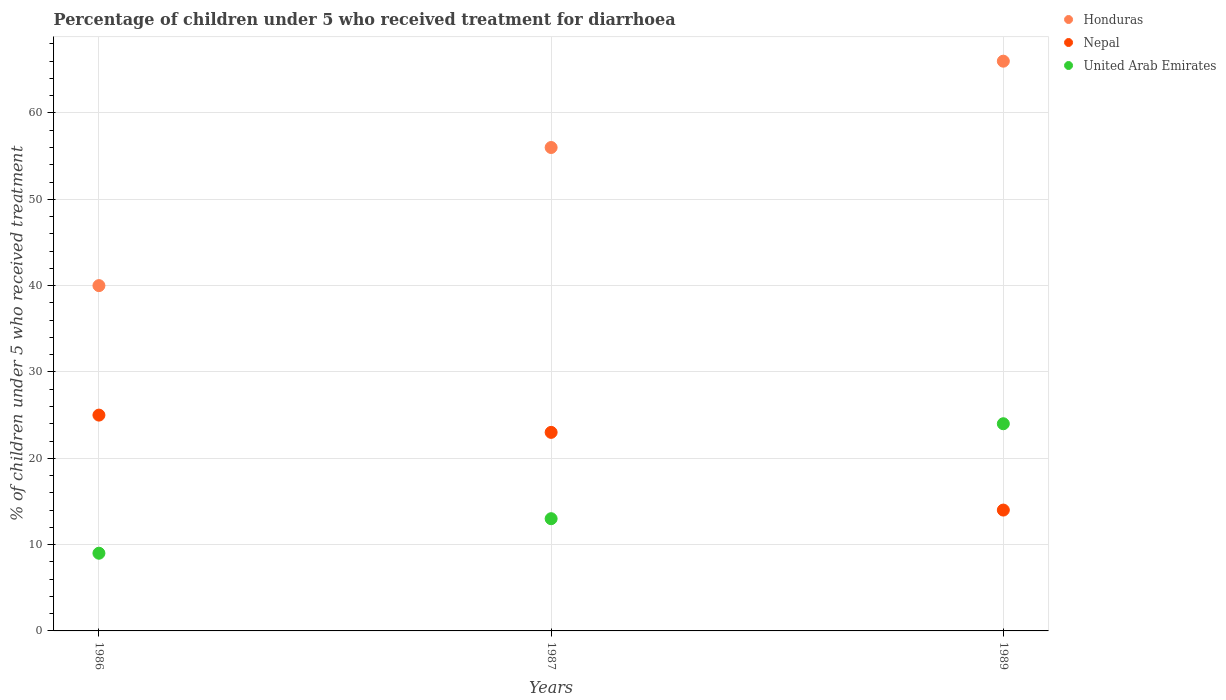How many different coloured dotlines are there?
Your answer should be compact. 3. Is the number of dotlines equal to the number of legend labels?
Make the answer very short. Yes. Across all years, what is the maximum percentage of children who received treatment for diarrhoea  in Nepal?
Keep it short and to the point. 25. In which year was the percentage of children who received treatment for diarrhoea  in Honduras maximum?
Provide a short and direct response. 1989. What is the total percentage of children who received treatment for diarrhoea  in United Arab Emirates in the graph?
Make the answer very short. 46. What is the difference between the percentage of children who received treatment for diarrhoea  in United Arab Emirates in 1987 and that in 1989?
Provide a short and direct response. -11. What is the average percentage of children who received treatment for diarrhoea  in United Arab Emirates per year?
Keep it short and to the point. 15.33. In how many years, is the percentage of children who received treatment for diarrhoea  in United Arab Emirates greater than 20 %?
Offer a very short reply. 1. What is the ratio of the percentage of children who received treatment for diarrhoea  in Nepal in 1986 to that in 1989?
Keep it short and to the point. 1.79. Is the sum of the percentage of children who received treatment for diarrhoea  in United Arab Emirates in 1987 and 1989 greater than the maximum percentage of children who received treatment for diarrhoea  in Nepal across all years?
Offer a terse response. Yes. Does the percentage of children who received treatment for diarrhoea  in United Arab Emirates monotonically increase over the years?
Make the answer very short. Yes. Is the percentage of children who received treatment for diarrhoea  in Nepal strictly greater than the percentage of children who received treatment for diarrhoea  in Honduras over the years?
Offer a very short reply. No. Is the percentage of children who received treatment for diarrhoea  in Nepal strictly less than the percentage of children who received treatment for diarrhoea  in Honduras over the years?
Ensure brevity in your answer.  Yes. How many years are there in the graph?
Provide a succinct answer. 3. Where does the legend appear in the graph?
Offer a terse response. Top right. What is the title of the graph?
Provide a short and direct response. Percentage of children under 5 who received treatment for diarrhoea. What is the label or title of the Y-axis?
Give a very brief answer. % of children under 5 who received treatment. What is the % of children under 5 who received treatment of Honduras in 1986?
Your answer should be very brief. 40. What is the % of children under 5 who received treatment in United Arab Emirates in 1986?
Give a very brief answer. 9. What is the % of children under 5 who received treatment in Nepal in 1989?
Give a very brief answer. 14. What is the % of children under 5 who received treatment of United Arab Emirates in 1989?
Keep it short and to the point. 24. Across all years, what is the maximum % of children under 5 who received treatment of Honduras?
Your answer should be very brief. 66. Across all years, what is the maximum % of children under 5 who received treatment of Nepal?
Your response must be concise. 25. Across all years, what is the minimum % of children under 5 who received treatment in Nepal?
Provide a short and direct response. 14. What is the total % of children under 5 who received treatment in Honduras in the graph?
Your answer should be very brief. 162. What is the total % of children under 5 who received treatment of Nepal in the graph?
Keep it short and to the point. 62. What is the difference between the % of children under 5 who received treatment in Honduras in 1986 and that in 1987?
Ensure brevity in your answer.  -16. What is the difference between the % of children under 5 who received treatment in Nepal in 1986 and that in 1987?
Keep it short and to the point. 2. What is the difference between the % of children under 5 who received treatment of United Arab Emirates in 1987 and that in 1989?
Provide a succinct answer. -11. What is the difference between the % of children under 5 who received treatment of Honduras in 1986 and the % of children under 5 who received treatment of Nepal in 1987?
Give a very brief answer. 17. What is the difference between the % of children under 5 who received treatment in Honduras in 1986 and the % of children under 5 who received treatment in United Arab Emirates in 1987?
Give a very brief answer. 27. What is the difference between the % of children under 5 who received treatment of Nepal in 1986 and the % of children under 5 who received treatment of United Arab Emirates in 1987?
Give a very brief answer. 12. What is the difference between the % of children under 5 who received treatment in Honduras in 1986 and the % of children under 5 who received treatment in Nepal in 1989?
Offer a terse response. 26. What is the difference between the % of children under 5 who received treatment of Nepal in 1986 and the % of children under 5 who received treatment of United Arab Emirates in 1989?
Make the answer very short. 1. What is the difference between the % of children under 5 who received treatment of Honduras in 1987 and the % of children under 5 who received treatment of United Arab Emirates in 1989?
Provide a succinct answer. 32. What is the average % of children under 5 who received treatment in Honduras per year?
Your answer should be very brief. 54. What is the average % of children under 5 who received treatment in Nepal per year?
Keep it short and to the point. 20.67. What is the average % of children under 5 who received treatment of United Arab Emirates per year?
Ensure brevity in your answer.  15.33. In the year 1986, what is the difference between the % of children under 5 who received treatment in Honduras and % of children under 5 who received treatment in Nepal?
Your response must be concise. 15. In the year 1987, what is the difference between the % of children under 5 who received treatment in Honduras and % of children under 5 who received treatment in Nepal?
Your response must be concise. 33. In the year 1987, what is the difference between the % of children under 5 who received treatment in Honduras and % of children under 5 who received treatment in United Arab Emirates?
Provide a short and direct response. 43. What is the ratio of the % of children under 5 who received treatment of Nepal in 1986 to that in 1987?
Your answer should be compact. 1.09. What is the ratio of the % of children under 5 who received treatment of United Arab Emirates in 1986 to that in 1987?
Offer a very short reply. 0.69. What is the ratio of the % of children under 5 who received treatment in Honduras in 1986 to that in 1989?
Give a very brief answer. 0.61. What is the ratio of the % of children under 5 who received treatment of Nepal in 1986 to that in 1989?
Your answer should be very brief. 1.79. What is the ratio of the % of children under 5 who received treatment of Honduras in 1987 to that in 1989?
Ensure brevity in your answer.  0.85. What is the ratio of the % of children under 5 who received treatment in Nepal in 1987 to that in 1989?
Provide a succinct answer. 1.64. What is the ratio of the % of children under 5 who received treatment of United Arab Emirates in 1987 to that in 1989?
Offer a terse response. 0.54. What is the difference between the highest and the second highest % of children under 5 who received treatment of Honduras?
Your answer should be compact. 10. What is the difference between the highest and the second highest % of children under 5 who received treatment of Nepal?
Provide a succinct answer. 2. What is the difference between the highest and the second highest % of children under 5 who received treatment in United Arab Emirates?
Offer a very short reply. 11. What is the difference between the highest and the lowest % of children under 5 who received treatment in Honduras?
Offer a terse response. 26. What is the difference between the highest and the lowest % of children under 5 who received treatment in United Arab Emirates?
Provide a short and direct response. 15. 